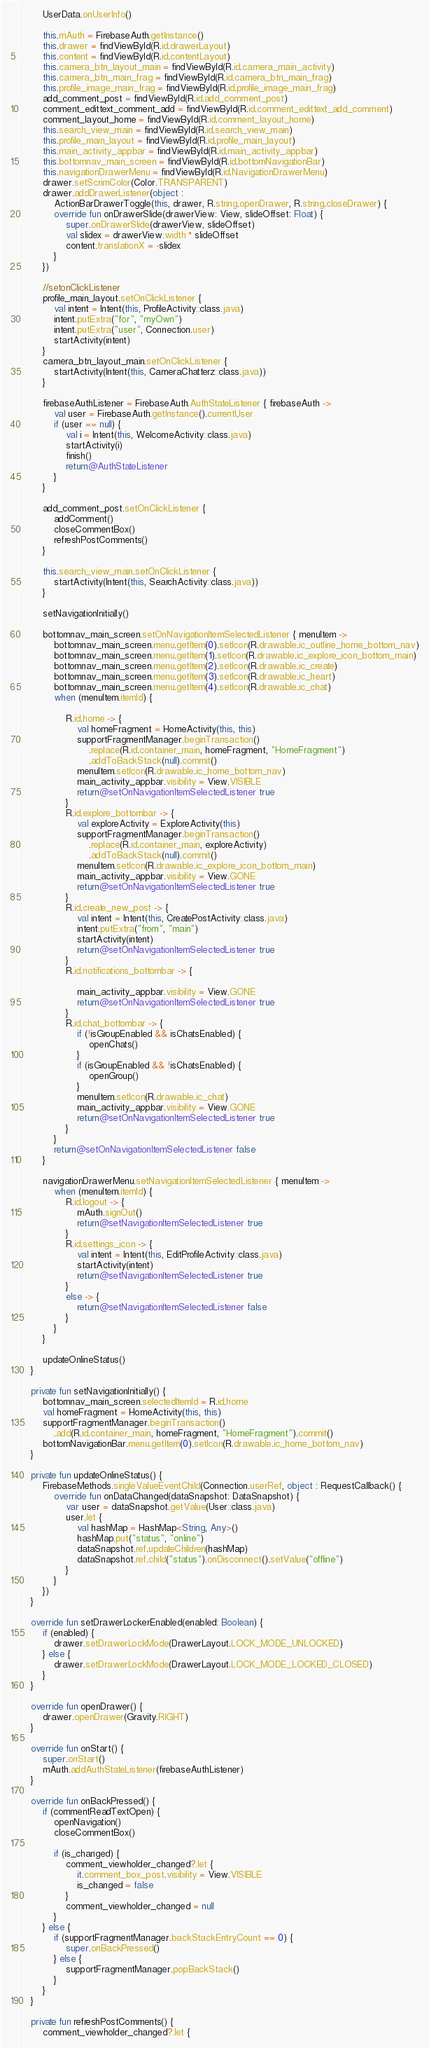Convert code to text. <code><loc_0><loc_0><loc_500><loc_500><_Kotlin_>
        UserData.onUserInfo()

        this.mAuth = FirebaseAuth.getInstance()
        this.drawer = findViewById(R.id.drawerLayout)
        this.content = findViewById(R.id.contentLayout)
        this.camera_btn_layout_main = findViewById(R.id.camera_main_activity)
        this.camera_btn_main_frag = findViewById(R.id.camera_btn_main_frag)
        this.profile_image_main_frag = findViewById(R.id.profile_image_main_frag)
        add_comment_post = findViewById(R.id.add_comment_post)
        comment_edittext_comment_add = findViewById(R.id.comment_edittext_add_comment)
        comment_layout_home = findViewById(R.id.comment_layout_home)
        this.search_view_main = findViewById(R.id.search_view_main)
        this.profile_main_layout = findViewById(R.id.profile_main_layout)
        this.main_activity_appbar = findViewById(R.id.main_activity_appbar)
        this.bottomnav_main_screen = findViewById(R.id.bottomNavigationBar)
        this.navigationDrawerMenu = findViewById(R.id.NavigationDrawerMenu)
        drawer.setScrimColor(Color.TRANSPARENT)
        drawer.addDrawerListener(object :
            ActionBarDrawerToggle(this, drawer, R.string.openDrawer, R.string.closeDrawer) {
            override fun onDrawerSlide(drawerView: View, slideOffset: Float) {
                super.onDrawerSlide(drawerView, slideOffset)
                val slidex = drawerView.width * slideOffset
                content.translationX = -slidex
            }
        })

        //setonClickListener
        profile_main_layout.setOnClickListener {
            val intent = Intent(this, ProfileActivity::class.java)
            intent.putExtra("for", "myOwn")
            intent.putExtra("user", Connection.user)
            startActivity(intent)
        }
        camera_btn_layout_main.setOnClickListener {
            startActivity(Intent(this, CameraChatterz::class.java))
        }

        firebaseAuthListener = FirebaseAuth.AuthStateListener { firebaseAuth ->
            val user = FirebaseAuth.getInstance().currentUser
            if (user == null) {
                val i = Intent(this, WelcomeActivity::class.java)
                startActivity(i)
                finish()
                return@AuthStateListener
            }
        }

        add_comment_post.setOnClickListener {
            addComment()
            closeCommentBox()
            refreshPostComments()
        }

        this.search_view_main.setOnClickListener {
            startActivity(Intent(this, SearchActivity::class.java))
        }

        setNavigationInitially()

        bottomnav_main_screen.setOnNavigationItemSelectedListener { menuItem ->
            bottomnav_main_screen.menu.getItem(0).setIcon(R.drawable.ic_outline_home_bottom_nav)
            bottomnav_main_screen.menu.getItem(1).setIcon(R.drawable.ic_explore_icon_bottom_main)
            bottomnav_main_screen.menu.getItem(2).setIcon(R.drawable.ic_create)
            bottomnav_main_screen.menu.getItem(3).setIcon(R.drawable.ic_heart)
            bottomnav_main_screen.menu.getItem(4).setIcon(R.drawable.ic_chat)
            when (menuItem.itemId) {

                R.id.home -> {
                    val homeFragment = HomeActivity(this, this)
                    supportFragmentManager.beginTransaction()
                        .replace(R.id.container_main, homeFragment, "HomeFragment")
                        .addToBackStack(null).commit()
                    menuItem.setIcon(R.drawable.ic_home_bottom_nav)
                    main_activity_appbar.visibility = View.VISIBLE
                    return@setOnNavigationItemSelectedListener true
                }
                R.id.explore_bottombar -> {
                    val exploreActivity = ExploreActivity(this)
                    supportFragmentManager.beginTransaction()
                        .replace(R.id.container_main, exploreActivity)
                        .addToBackStack(null).commit()
                    menuItem.setIcon(R.drawable.ic_explore_icon_bottom_main)
                    main_activity_appbar.visibility = View.GONE
                    return@setOnNavigationItemSelectedListener true
                }
                R.id.create_new_post -> {
                    val intent = Intent(this, CreatePostActivity::class.java)
                    intent.putExtra("from", "main")
                    startActivity(intent)
                    return@setOnNavigationItemSelectedListener true
                }
                R.id.notifications_bottombar -> {

                    main_activity_appbar.visibility = View.GONE
                    return@setOnNavigationItemSelectedListener true
                }
                R.id.chat_bottombar -> {
                    if (!isGroupEnabled && isChatsEnabled) {
                        openChats()
                    }
                    if (isGroupEnabled && !isChatsEnabled) {
                        openGroup()
                    }
                    menuItem.setIcon(R.drawable.ic_chat)
                    main_activity_appbar.visibility = View.GONE
                    return@setOnNavigationItemSelectedListener true
                }
            }
            return@setOnNavigationItemSelectedListener false
        }

        navigationDrawerMenu.setNavigationItemSelectedListener { menuItem ->
            when (menuItem.itemId) {
                R.id.logout -> {
                    mAuth.signOut()
                    return@setNavigationItemSelectedListener true
                }
                R.id.settings_icon -> {
                    val intent = Intent(this, EditProfileActivity::class.java)
                    startActivity(intent)
                    return@setNavigationItemSelectedListener true
                }
                else -> {
                    return@setNavigationItemSelectedListener false
                }
            }
        }

        updateOnlineStatus()
    }

    private fun setNavigationInitially() {
        bottomnav_main_screen.selectedItemId = R.id.home
        val homeFragment = HomeActivity(this, this)
        supportFragmentManager.beginTransaction()
            .add(R.id.container_main, homeFragment, "HomeFragment").commit()
        bottomNavigationBar.menu.getItem(0).setIcon(R.drawable.ic_home_bottom_nav)
    }

    private fun updateOnlineStatus() {
        FirebaseMethods.singleValueEventChild(Connection.userRef, object : RequestCallback() {
            override fun onDataChanged(dataSnapshot: DataSnapshot) {
                var user = dataSnapshot.getValue(User::class.java)
                user.let {
                    val hashMap = HashMap<String, Any>()
                    hashMap.put("status", "online")
                    dataSnapshot.ref.updateChildren(hashMap)
                    dataSnapshot.ref.child("status").onDisconnect().setValue("offline")
                }
            }
        })
    }

    override fun setDrawerLockerEnabled(enabled: Boolean) {
        if (enabled) {
            drawer.setDrawerLockMode(DrawerLayout.LOCK_MODE_UNLOCKED)
        } else {
            drawer.setDrawerLockMode(DrawerLayout.LOCK_MODE_LOCKED_CLOSED)
        }
    }

    override fun openDrawer() {
        drawer.openDrawer(Gravity.RIGHT)
    }

    override fun onStart() {
        super.onStart()
        mAuth.addAuthStateListener(firebaseAuthListener)
    }

    override fun onBackPressed() {
        if (commentReadTextOpen) {
            openNavigation()
            closeCommentBox()

            if (is_changed) {
                comment_viewholder_changed?.let {
                    it.comment_box_post.visibility = View.VISIBLE
                    is_changed = false
                }
                comment_viewholder_changed = null
            }
        } else {
            if (supportFragmentManager.backStackEntryCount == 0) {
                super.onBackPressed()
            } else {
                supportFragmentManager.popBackStack()
            }
        }
    }

    private fun refreshPostComments() {
        comment_viewholder_changed?.let {</code> 